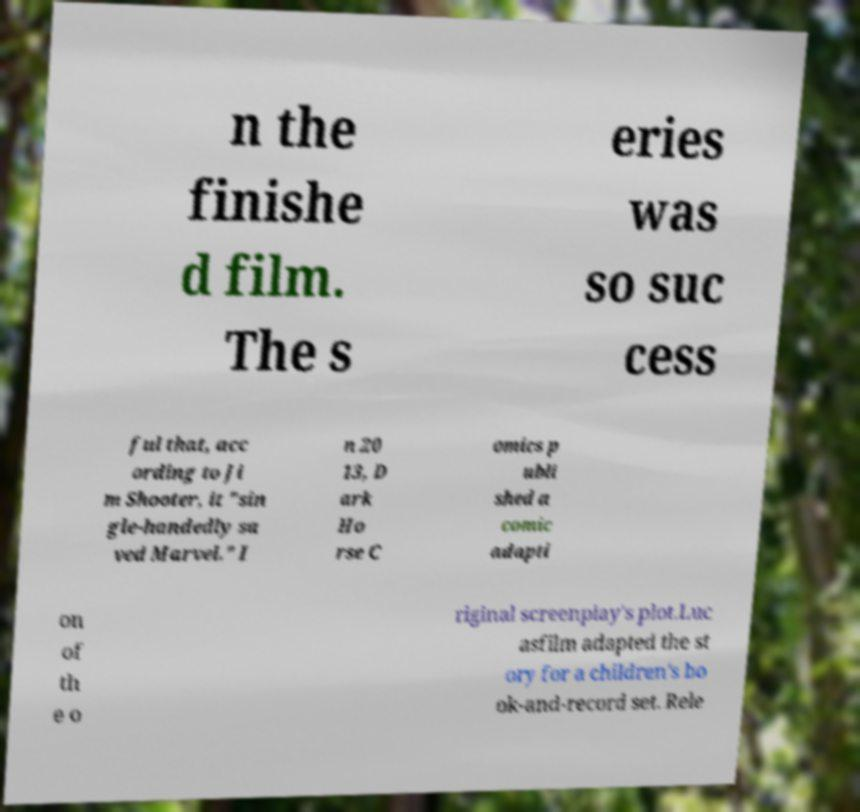Please identify and transcribe the text found in this image. n the finishe d film. The s eries was so suc cess ful that, acc ording to Ji m Shooter, it "sin gle-handedly sa ved Marvel." I n 20 13, D ark Ho rse C omics p ubli shed a comic adapti on of th e o riginal screenplay's plot.Luc asfilm adapted the st ory for a children's bo ok-and-record set. Rele 